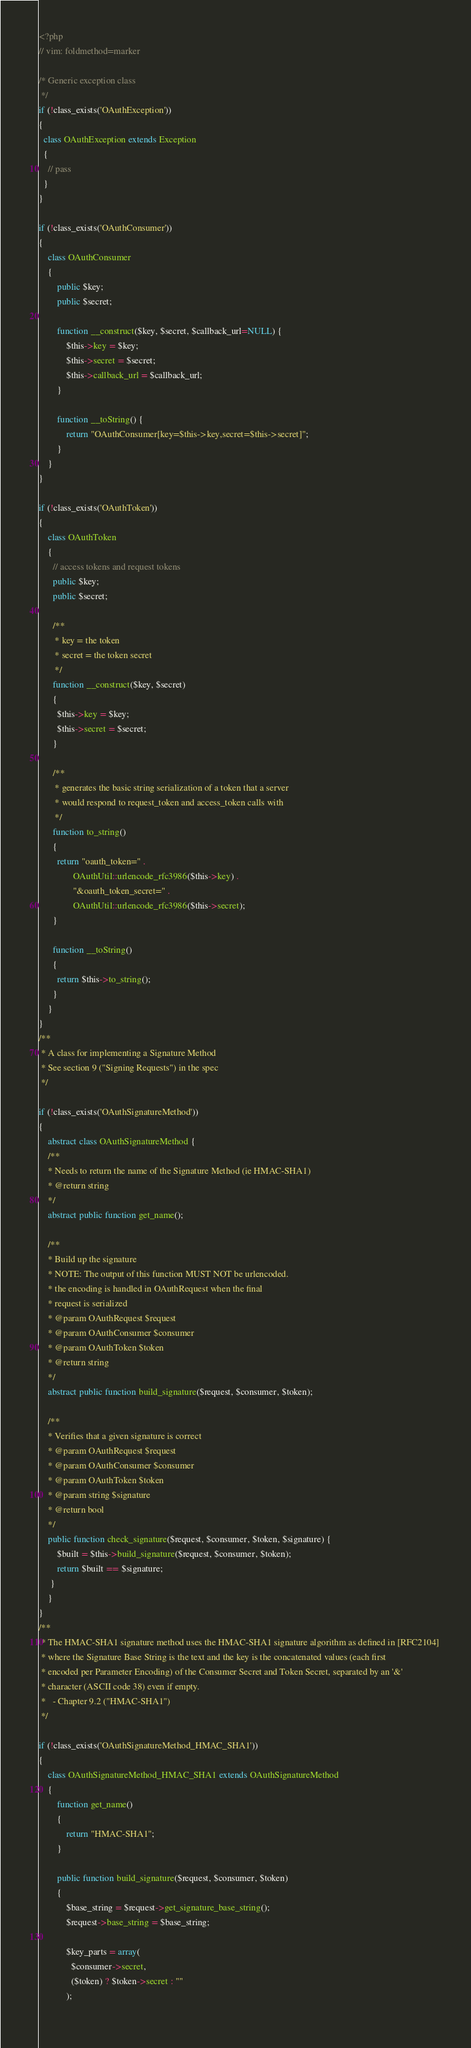<code> <loc_0><loc_0><loc_500><loc_500><_PHP_><?php
// vim: foldmethod=marker

/* Generic exception class
 */
if (!class_exists('OAuthException'))
{
  class OAuthException extends Exception
  {
    // pass
  }
}

if (!class_exists('OAuthConsumer'))
{
	class OAuthConsumer
	{
		public $key;
	  	public $secret;
	
		function __construct($key, $secret, $callback_url=NULL) {
			$this->key = $key;
			$this->secret = $secret;
			$this->callback_url = $callback_url;
		}
		
		function __toString() {
			return "OAuthConsumer[key=$this->key,secret=$this->secret]";
		}
	}
}

if (!class_exists('OAuthToken'))
{
	class OAuthToken
	{
	  // access tokens and request tokens
	  public $key;
	  public $secret;
	
	  /**
	   * key = the token
	   * secret = the token secret
	   */
	  function __construct($key, $secret)
	  {
		$this->key = $key;
		$this->secret = $secret;
	  }
	
	  /**
	   * generates the basic string serialization of a token that a server
	   * would respond to request_token and access_token calls with
	   */
	  function to_string()
	  {
		return "oauth_token=" .
			   OAuthUtil::urlencode_rfc3986($this->key) .
			   "&oauth_token_secret=" .
			   OAuthUtil::urlencode_rfc3986($this->secret);
	  }
	
	  function __toString()
	  {
		return $this->to_string();
	  }
	}
}
/**
 * A class for implementing a Signature Method
 * See section 9 ("Signing Requests") in the spec
 */
 
if (!class_exists('OAuthSignatureMethod'))
{
	abstract class OAuthSignatureMethod {
	/**
	* Needs to return the name of the Signature Method (ie HMAC-SHA1)
	* @return string
	*/
	abstract public function get_name();
	
	/**
	* Build up the signature
	* NOTE: The output of this function MUST NOT be urlencoded.
	* the encoding is handled in OAuthRequest when the final
	* request is serialized
	* @param OAuthRequest $request
	* @param OAuthConsumer $consumer
	* @param OAuthToken $token
	* @return string
	*/
	abstract public function build_signature($request, $consumer, $token);
	
	/**
	* Verifies that a given signature is correct
	* @param OAuthRequest $request
	* @param OAuthConsumer $consumer
	* @param OAuthToken $token
	* @param string $signature
	* @return bool
	*/
	public function check_signature($request, $consumer, $token, $signature) {
		$built = $this->build_signature($request, $consumer, $token);
		return $built == $signature;
 	 }
	}
}
/**
 * The HMAC-SHA1 signature method uses the HMAC-SHA1 signature algorithm as defined in [RFC2104] 
 * where the Signature Base String is the text and the key is the concatenated values (each first 
 * encoded per Parameter Encoding) of the Consumer Secret and Token Secret, separated by an '&' 
 * character (ASCII code 38) even if empty.
 *   - Chapter 9.2 ("HMAC-SHA1")
 */
 
if (!class_exists('OAuthSignatureMethod_HMAC_SHA1'))
{
	class OAuthSignatureMethod_HMAC_SHA1 extends OAuthSignatureMethod
	{
		function get_name()
		{
			return "HMAC-SHA1";
		}
		
		public function build_signature($request, $consumer, $token)
		{
			$base_string = $request->get_signature_base_string();
			$request->base_string = $base_string;
			
			$key_parts = array(
			  $consumer->secret,
			  ($token) ? $token->secret : ""
			);
			</code> 